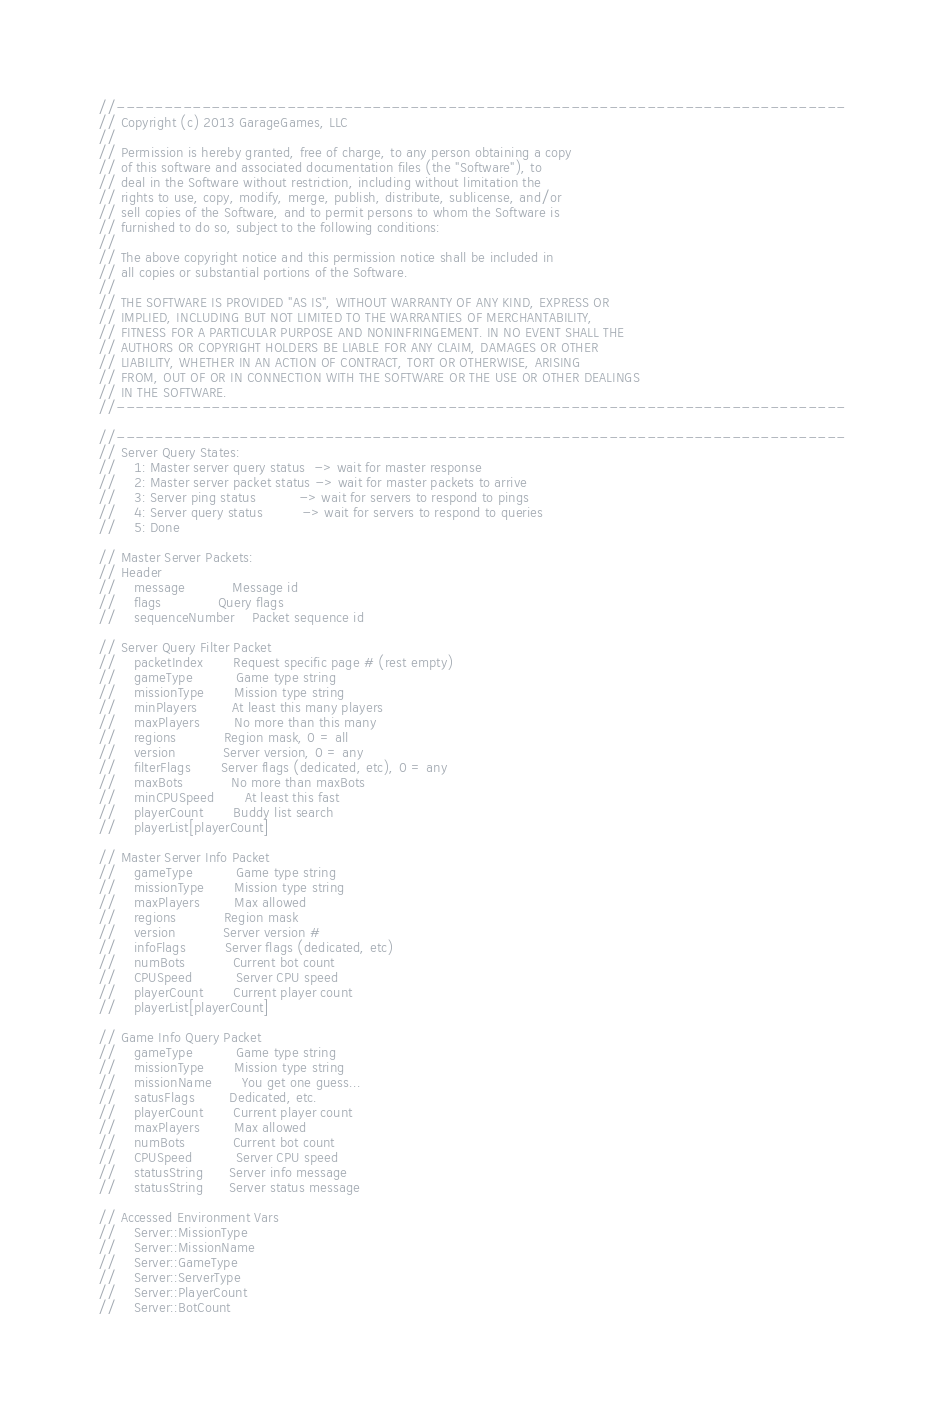<code> <loc_0><loc_0><loc_500><loc_500><_C++_>//-----------------------------------------------------------------------------
// Copyright (c) 2013 GarageGames, LLC
//
// Permission is hereby granted, free of charge, to any person obtaining a copy
// of this software and associated documentation files (the "Software"), to
// deal in the Software without restriction, including without limitation the
// rights to use, copy, modify, merge, publish, distribute, sublicense, and/or
// sell copies of the Software, and to permit persons to whom the Software is
// furnished to do so, subject to the following conditions:
//
// The above copyright notice and this permission notice shall be included in
// all copies or substantial portions of the Software.
//
// THE SOFTWARE IS PROVIDED "AS IS", WITHOUT WARRANTY OF ANY KIND, EXPRESS OR
// IMPLIED, INCLUDING BUT NOT LIMITED TO THE WARRANTIES OF MERCHANTABILITY,
// FITNESS FOR A PARTICULAR PURPOSE AND NONINFRINGEMENT. IN NO EVENT SHALL THE
// AUTHORS OR COPYRIGHT HOLDERS BE LIABLE FOR ANY CLAIM, DAMAGES OR OTHER
// LIABILITY, WHETHER IN AN ACTION OF CONTRACT, TORT OR OTHERWISE, ARISING
// FROM, OUT OF OR IN CONNECTION WITH THE SOFTWARE OR THE USE OR OTHER DEALINGS
// IN THE SOFTWARE.
//-----------------------------------------------------------------------------

//-----------------------------------------------------------------------------
// Server Query States:
//    1: Master server query status  -> wait for master response
//    2: Master server packet status -> wait for master packets to arrive
//    3: Server ping status          -> wait for servers to respond to pings
//    4: Server query status         -> wait for servers to respond to queries
//    5: Done

// Master Server Packets:
// Header
//    message           Message id
//    flags             Query flags
//    sequenceNumber    Packet sequence id

// Server Query Filter Packet
//    packetIndex       Request specific page # (rest empty)
//    gameType          Game type string
//    missionType       Mission type string
//    minPlayers        At least this many players
//    maxPlayers        No more than this many
//    regions           Region mask, 0 = all
//    version           Server version, 0 = any
//    filterFlags       Server flags (dedicated, etc), 0 = any
//    maxBots           No more than maxBots
//    minCPUSpeed       At least this fast
//    playerCount       Buddy list search
//    playerList[playerCount]

// Master Server Info Packet
//    gameType          Game type string
//    missionType       Mission type string
//    maxPlayers        Max allowed
//    regions           Region mask
//    version           Server version #
//    infoFlags         Server flags (dedicated, etc)
//    numBots           Current bot count
//    CPUSpeed          Server CPU speed
//    playerCount       Current player count
//    playerList[playerCount]

// Game Info Query Packet
//    gameType          Game type string
//    missionType       Mission type string
//    missionName       You get one guess...
//    satusFlags        Dedicated, etc.
//    playerCount       Current player count
//    maxPlayers        Max allowed
//    numBots           Current bot count
//    CPUSpeed          Server CPU speed
//    statusString      Server info message
//    statusString      Server status message

// Accessed Environment Vars
//    Server::MissionType
//    Server::MissionName
//    Server::GameType
//    Server::ServerType
//    Server::PlayerCount
//    Server::BotCount</code> 